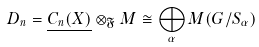<formula> <loc_0><loc_0><loc_500><loc_500>D _ { n } = \underline { C _ { n } ( X ) } \otimes _ { \mathfrak { F } } M \cong \bigoplus _ { \alpha } M ( G / S _ { \alpha } ) \,</formula> 